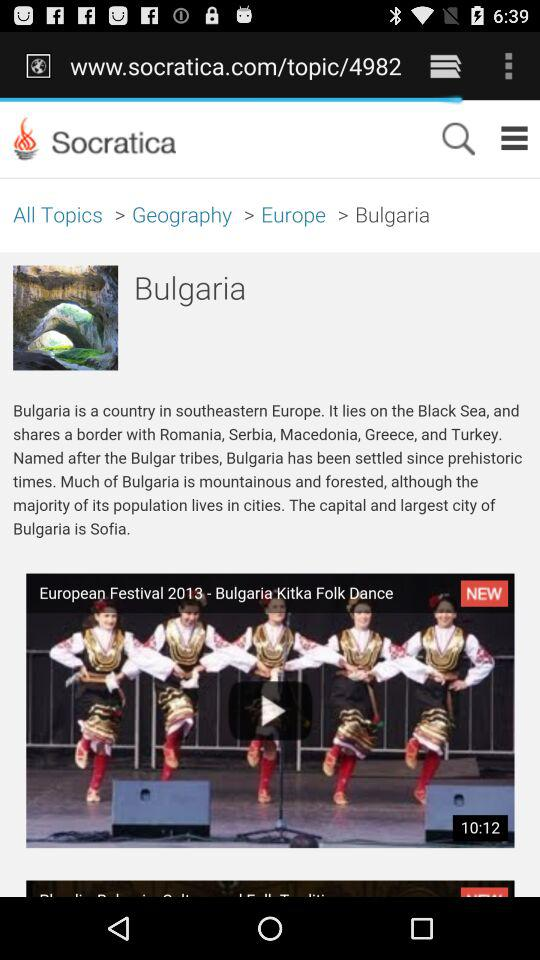What is the duration of the video? The duration is 10 minutes 12 seconds. 